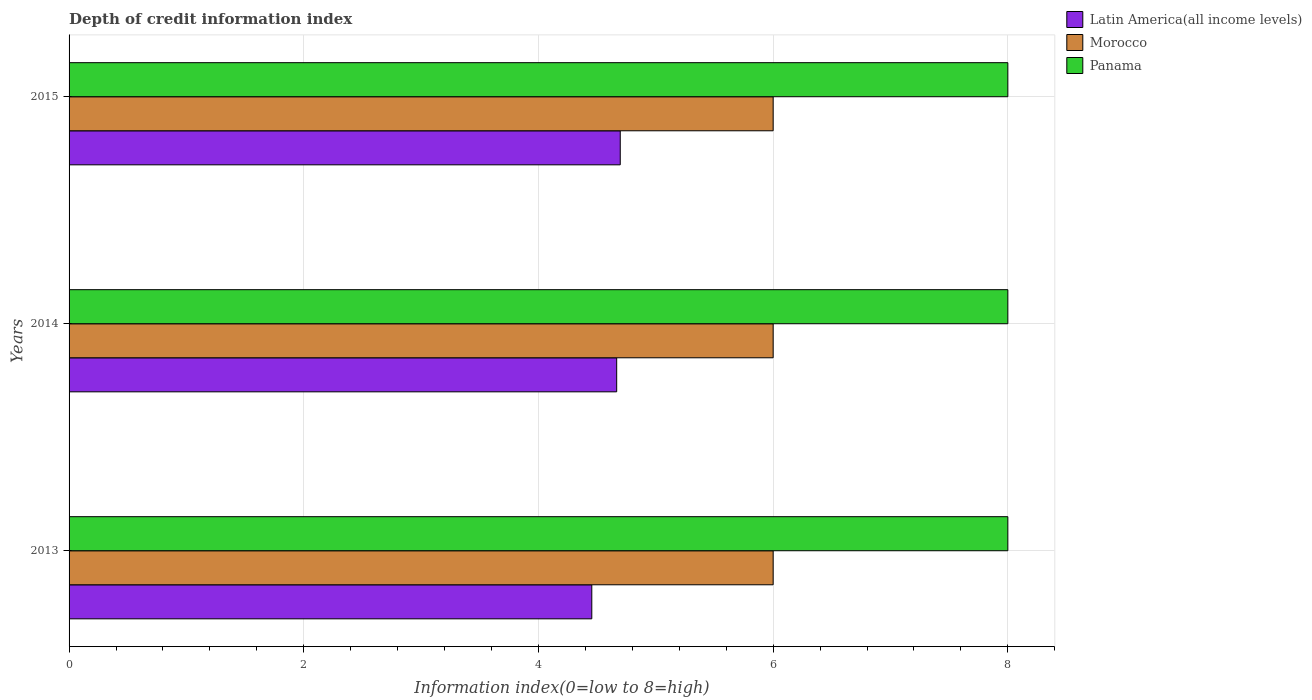How many groups of bars are there?
Offer a very short reply. 3. How many bars are there on the 1st tick from the bottom?
Offer a terse response. 3. What is the information index in Latin America(all income levels) in 2015?
Keep it short and to the point. 4.7. Across all years, what is the maximum information index in Latin America(all income levels)?
Provide a short and direct response. 4.7. Across all years, what is the minimum information index in Morocco?
Give a very brief answer. 6. In which year was the information index in Latin America(all income levels) maximum?
Your answer should be compact. 2015. In which year was the information index in Panama minimum?
Provide a succinct answer. 2013. What is the total information index in Panama in the graph?
Ensure brevity in your answer.  24. What is the difference between the information index in Panama in 2014 and the information index in Morocco in 2013?
Your answer should be very brief. 2. In the year 2013, what is the difference between the information index in Morocco and information index in Panama?
Make the answer very short. -2. In how many years, is the information index in Panama greater than 4.4 ?
Keep it short and to the point. 3. Is the information index in Panama in 2013 less than that in 2015?
Your answer should be very brief. No. What is the difference between the highest and the lowest information index in Latin America(all income levels)?
Your answer should be compact. 0.24. Is the sum of the information index in Panama in 2014 and 2015 greater than the maximum information index in Latin America(all income levels) across all years?
Keep it short and to the point. Yes. What does the 3rd bar from the top in 2014 represents?
Your answer should be very brief. Latin America(all income levels). What does the 1st bar from the bottom in 2013 represents?
Keep it short and to the point. Latin America(all income levels). Is it the case that in every year, the sum of the information index in Morocco and information index in Panama is greater than the information index in Latin America(all income levels)?
Ensure brevity in your answer.  Yes. How many bars are there?
Offer a terse response. 9. Are all the bars in the graph horizontal?
Keep it short and to the point. Yes. How many years are there in the graph?
Your answer should be compact. 3. Does the graph contain grids?
Your response must be concise. Yes. How are the legend labels stacked?
Your answer should be very brief. Vertical. What is the title of the graph?
Offer a terse response. Depth of credit information index. What is the label or title of the X-axis?
Give a very brief answer. Information index(0=low to 8=high). What is the Information index(0=low to 8=high) of Latin America(all income levels) in 2013?
Provide a succinct answer. 4.45. What is the Information index(0=low to 8=high) in Morocco in 2013?
Provide a short and direct response. 6. What is the Information index(0=low to 8=high) in Panama in 2013?
Ensure brevity in your answer.  8. What is the Information index(0=low to 8=high) of Latin America(all income levels) in 2014?
Make the answer very short. 4.67. What is the Information index(0=low to 8=high) in Latin America(all income levels) in 2015?
Your answer should be compact. 4.7. What is the Information index(0=low to 8=high) of Panama in 2015?
Provide a short and direct response. 8. Across all years, what is the maximum Information index(0=low to 8=high) in Latin America(all income levels)?
Offer a terse response. 4.7. Across all years, what is the maximum Information index(0=low to 8=high) of Morocco?
Your response must be concise. 6. Across all years, what is the minimum Information index(0=low to 8=high) in Latin America(all income levels)?
Give a very brief answer. 4.45. Across all years, what is the minimum Information index(0=low to 8=high) of Morocco?
Offer a terse response. 6. What is the total Information index(0=low to 8=high) of Latin America(all income levels) in the graph?
Your answer should be very brief. 13.82. What is the total Information index(0=low to 8=high) in Morocco in the graph?
Provide a succinct answer. 18. What is the difference between the Information index(0=low to 8=high) in Latin America(all income levels) in 2013 and that in 2014?
Offer a terse response. -0.21. What is the difference between the Information index(0=low to 8=high) in Morocco in 2013 and that in 2014?
Give a very brief answer. 0. What is the difference between the Information index(0=low to 8=high) of Panama in 2013 and that in 2014?
Provide a short and direct response. 0. What is the difference between the Information index(0=low to 8=high) of Latin America(all income levels) in 2013 and that in 2015?
Offer a very short reply. -0.24. What is the difference between the Information index(0=low to 8=high) in Morocco in 2013 and that in 2015?
Your answer should be very brief. 0. What is the difference between the Information index(0=low to 8=high) in Latin America(all income levels) in 2014 and that in 2015?
Your answer should be very brief. -0.03. What is the difference between the Information index(0=low to 8=high) in Panama in 2014 and that in 2015?
Provide a succinct answer. 0. What is the difference between the Information index(0=low to 8=high) of Latin America(all income levels) in 2013 and the Information index(0=low to 8=high) of Morocco in 2014?
Your response must be concise. -1.55. What is the difference between the Information index(0=low to 8=high) of Latin America(all income levels) in 2013 and the Information index(0=low to 8=high) of Panama in 2014?
Make the answer very short. -3.55. What is the difference between the Information index(0=low to 8=high) in Latin America(all income levels) in 2013 and the Information index(0=low to 8=high) in Morocco in 2015?
Offer a terse response. -1.55. What is the difference between the Information index(0=low to 8=high) in Latin America(all income levels) in 2013 and the Information index(0=low to 8=high) in Panama in 2015?
Offer a terse response. -3.55. What is the difference between the Information index(0=low to 8=high) of Morocco in 2013 and the Information index(0=low to 8=high) of Panama in 2015?
Provide a short and direct response. -2. What is the difference between the Information index(0=low to 8=high) in Latin America(all income levels) in 2014 and the Information index(0=low to 8=high) in Morocco in 2015?
Ensure brevity in your answer.  -1.33. What is the difference between the Information index(0=low to 8=high) of Morocco in 2014 and the Information index(0=low to 8=high) of Panama in 2015?
Your response must be concise. -2. What is the average Information index(0=low to 8=high) in Latin America(all income levels) per year?
Your answer should be compact. 4.61. In the year 2013, what is the difference between the Information index(0=low to 8=high) of Latin America(all income levels) and Information index(0=low to 8=high) of Morocco?
Provide a succinct answer. -1.55. In the year 2013, what is the difference between the Information index(0=low to 8=high) of Latin America(all income levels) and Information index(0=low to 8=high) of Panama?
Make the answer very short. -3.55. In the year 2014, what is the difference between the Information index(0=low to 8=high) of Latin America(all income levels) and Information index(0=low to 8=high) of Morocco?
Ensure brevity in your answer.  -1.33. In the year 2015, what is the difference between the Information index(0=low to 8=high) of Latin America(all income levels) and Information index(0=low to 8=high) of Morocco?
Make the answer very short. -1.3. In the year 2015, what is the difference between the Information index(0=low to 8=high) of Latin America(all income levels) and Information index(0=low to 8=high) of Panama?
Your response must be concise. -3.3. In the year 2015, what is the difference between the Information index(0=low to 8=high) in Morocco and Information index(0=low to 8=high) in Panama?
Ensure brevity in your answer.  -2. What is the ratio of the Information index(0=low to 8=high) in Latin America(all income levels) in 2013 to that in 2014?
Ensure brevity in your answer.  0.95. What is the ratio of the Information index(0=low to 8=high) in Morocco in 2013 to that in 2014?
Ensure brevity in your answer.  1. What is the ratio of the Information index(0=low to 8=high) in Panama in 2013 to that in 2014?
Give a very brief answer. 1. What is the ratio of the Information index(0=low to 8=high) of Latin America(all income levels) in 2013 to that in 2015?
Provide a succinct answer. 0.95. What is the ratio of the Information index(0=low to 8=high) of Latin America(all income levels) in 2014 to that in 2015?
Give a very brief answer. 0.99. What is the ratio of the Information index(0=low to 8=high) of Morocco in 2014 to that in 2015?
Provide a succinct answer. 1. What is the ratio of the Information index(0=low to 8=high) in Panama in 2014 to that in 2015?
Offer a very short reply. 1. What is the difference between the highest and the second highest Information index(0=low to 8=high) in Latin America(all income levels)?
Offer a very short reply. 0.03. What is the difference between the highest and the lowest Information index(0=low to 8=high) in Latin America(all income levels)?
Make the answer very short. 0.24. What is the difference between the highest and the lowest Information index(0=low to 8=high) of Morocco?
Offer a terse response. 0. What is the difference between the highest and the lowest Information index(0=low to 8=high) of Panama?
Offer a very short reply. 0. 